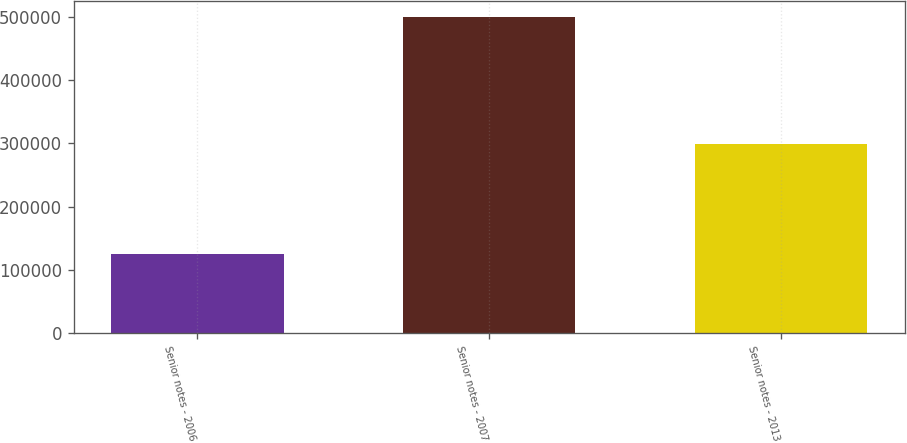<chart> <loc_0><loc_0><loc_500><loc_500><bar_chart><fcel>Senior notes - 2006<fcel>Senior notes - 2007<fcel>Senior notes - 2013<nl><fcel>125000<fcel>500000<fcel>299809<nl></chart> 